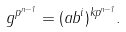Convert formula to latex. <formula><loc_0><loc_0><loc_500><loc_500>g ^ { p ^ { n - 1 } } = ( a b ^ { i } ) ^ { k p ^ { n - 1 } } .</formula> 